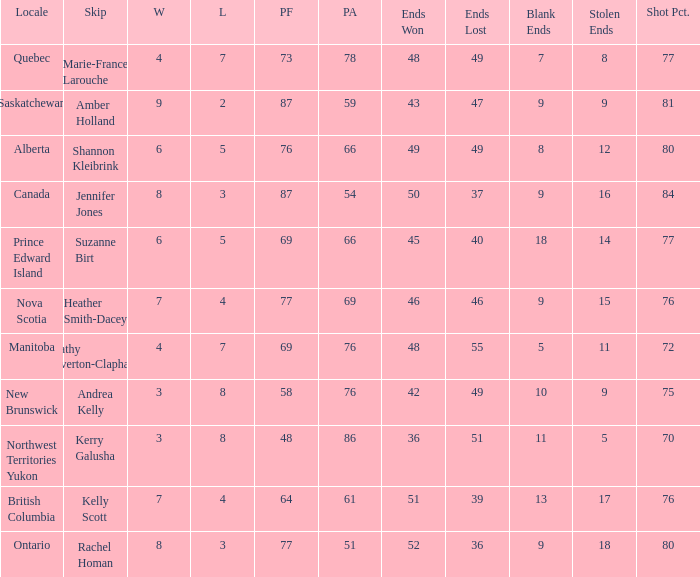If the skip is Kelly Scott, what is the PF total number? 1.0. Can you parse all the data within this table? {'header': ['Locale', 'Skip', 'W', 'L', 'PF', 'PA', 'Ends Won', 'Ends Lost', 'Blank Ends', 'Stolen Ends', 'Shot Pct.'], 'rows': [['Quebec', 'Marie-France Larouche', '4', '7', '73', '78', '48', '49', '7', '8', '77'], ['Saskatchewan', 'Amber Holland', '9', '2', '87', '59', '43', '47', '9', '9', '81'], ['Alberta', 'Shannon Kleibrink', '6', '5', '76', '66', '49', '49', '8', '12', '80'], ['Canada', 'Jennifer Jones', '8', '3', '87', '54', '50', '37', '9', '16', '84'], ['Prince Edward Island', 'Suzanne Birt', '6', '5', '69', '66', '45', '40', '18', '14', '77'], ['Nova Scotia', 'Heather Smith-Dacey', '7', '4', '77', '69', '46', '46', '9', '15', '76'], ['Manitoba', 'Cathy Overton-Clapham', '4', '7', '69', '76', '48', '55', '5', '11', '72'], ['New Brunswick', 'Andrea Kelly', '3', '8', '58', '76', '42', '49', '10', '9', '75'], ['Northwest Territories Yukon', 'Kerry Galusha', '3', '8', '48', '86', '36', '51', '11', '5', '70'], ['British Columbia', 'Kelly Scott', '7', '4', '64', '61', '51', '39', '13', '17', '76'], ['Ontario', 'Rachel Homan', '8', '3', '77', '51', '52', '36', '9', '18', '80']]} 